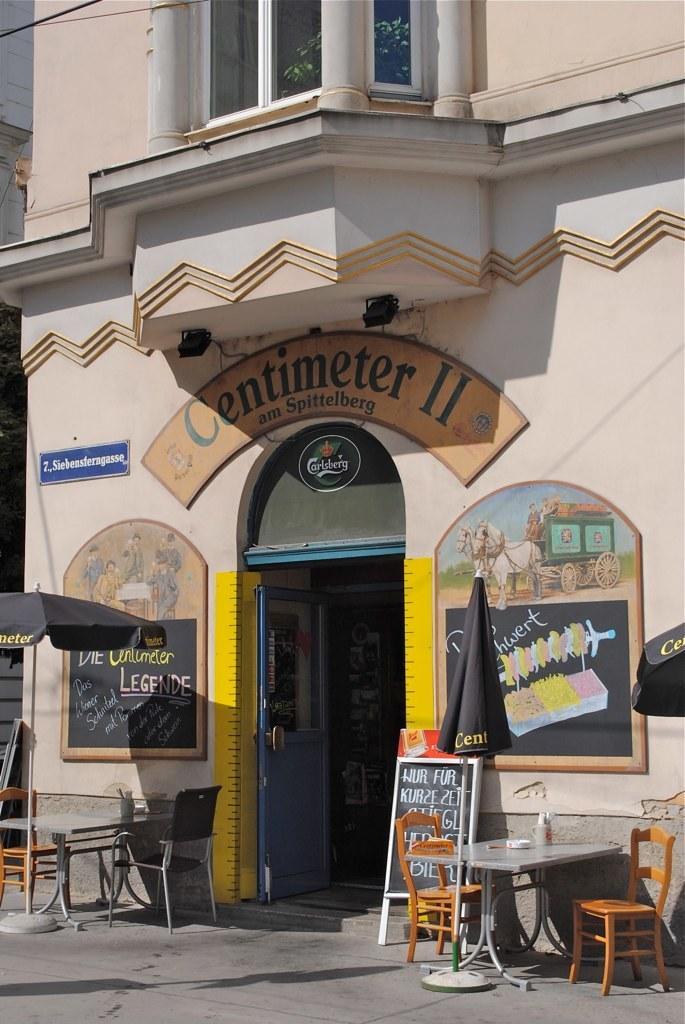Could you give a brief overview of what you see in this image? Here in this picture we can see front of a building, as we can see its door and a window present and we can see an umbrella with table and chairs under it over there and we can see board present on either side of the door over there. 